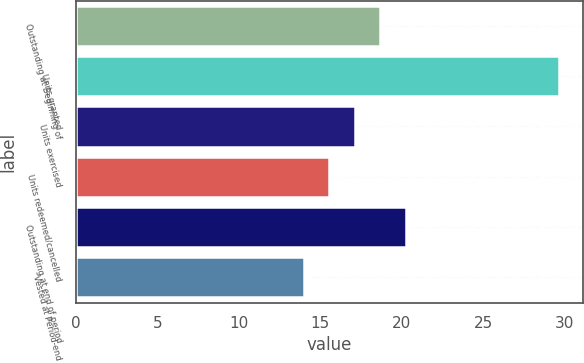<chart> <loc_0><loc_0><loc_500><loc_500><bar_chart><fcel>Outstanding at Beginning of<fcel>Units granted<fcel>Units exercised<fcel>Units redeemed/cancelled<fcel>Outstanding at end of period<fcel>Vested at Period-end<nl><fcel>18.68<fcel>29.65<fcel>17.11<fcel>15.54<fcel>20.25<fcel>13.97<nl></chart> 